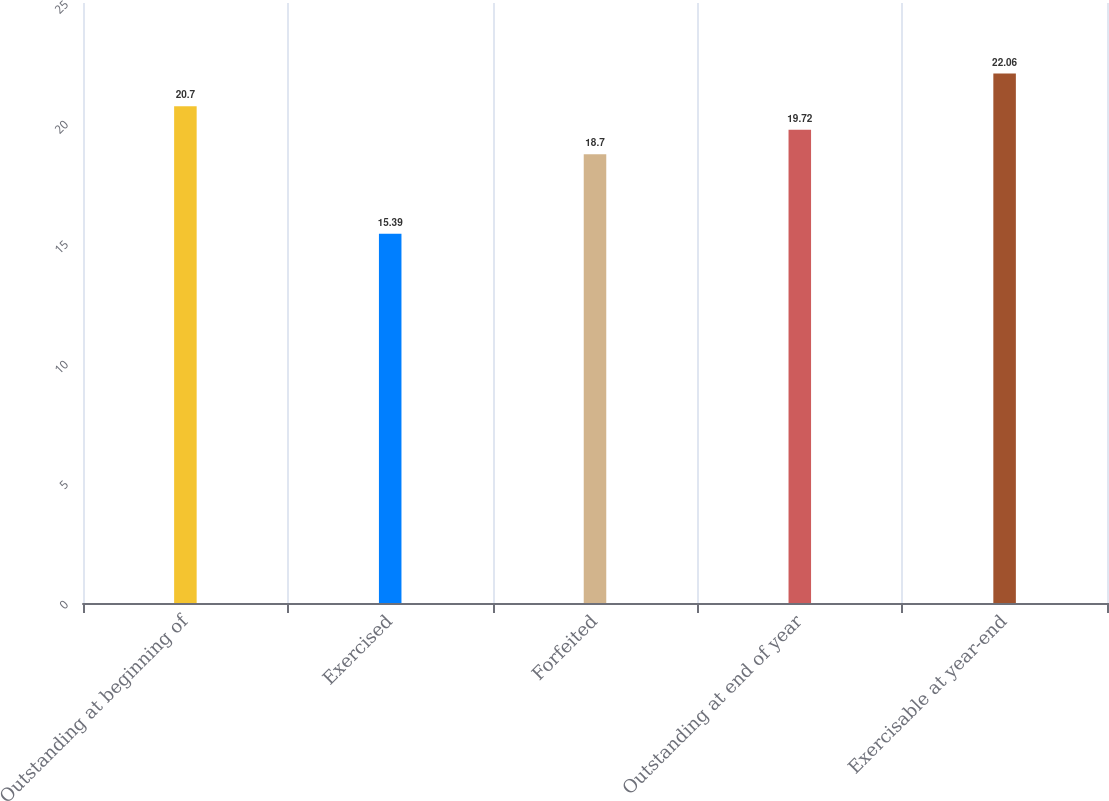<chart> <loc_0><loc_0><loc_500><loc_500><bar_chart><fcel>Outstanding at beginning of<fcel>Exercised<fcel>Forfeited<fcel>Outstanding at end of year<fcel>Exercisable at year-end<nl><fcel>20.7<fcel>15.39<fcel>18.7<fcel>19.72<fcel>22.06<nl></chart> 